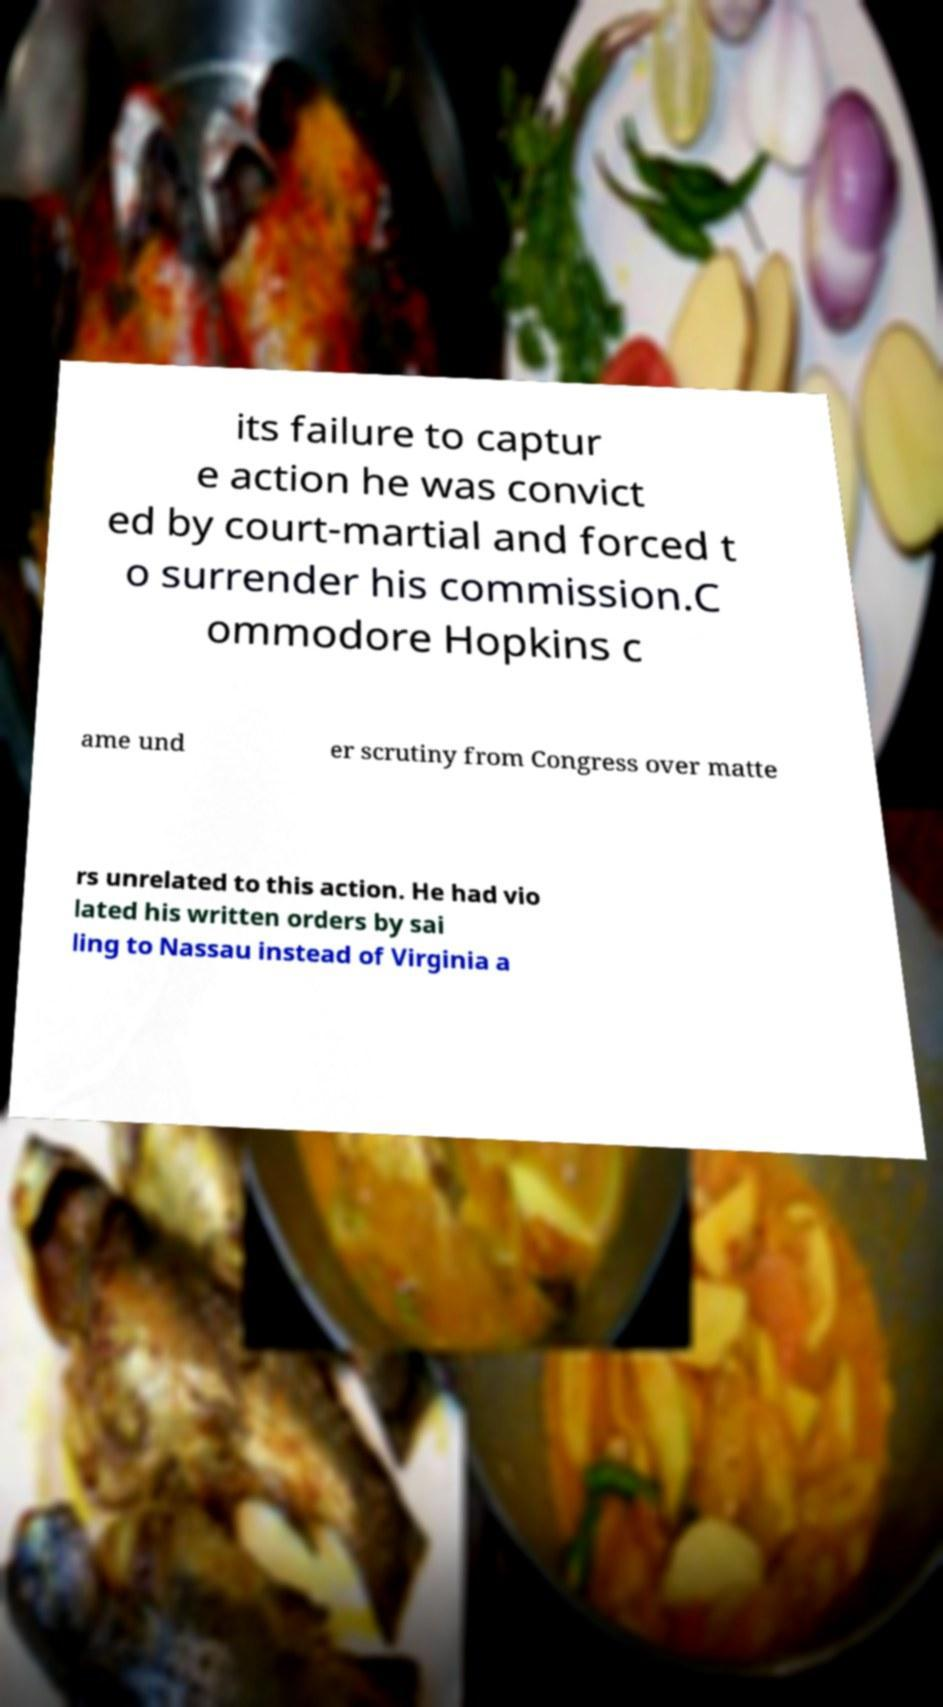Can you accurately transcribe the text from the provided image for me? its failure to captur e action he was convict ed by court-martial and forced t o surrender his commission.C ommodore Hopkins c ame und er scrutiny from Congress over matte rs unrelated to this action. He had vio lated his written orders by sai ling to Nassau instead of Virginia a 